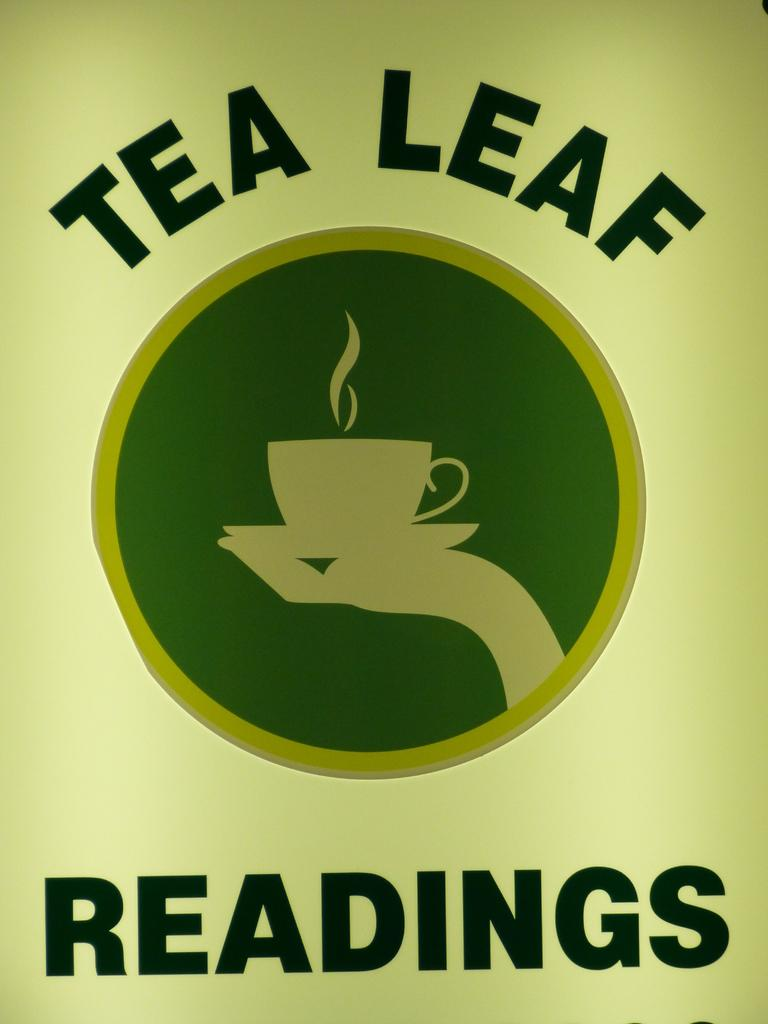<image>
Write a terse but informative summary of the picture. A picture of a hand holding a steaming teacup which reads Tea Leaf Readings. 